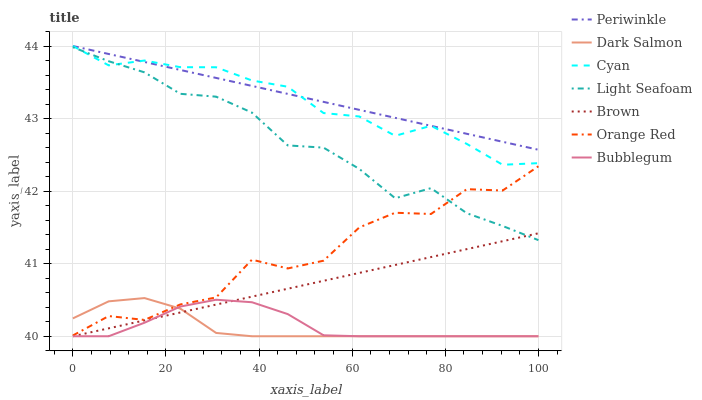Does Dark Salmon have the minimum area under the curve?
Answer yes or no. Yes. Does Periwinkle have the maximum area under the curve?
Answer yes or no. Yes. Does Bubblegum have the minimum area under the curve?
Answer yes or no. No. Does Bubblegum have the maximum area under the curve?
Answer yes or no. No. Is Brown the smoothest?
Answer yes or no. Yes. Is Orange Red the roughest?
Answer yes or no. Yes. Is Dark Salmon the smoothest?
Answer yes or no. No. Is Dark Salmon the roughest?
Answer yes or no. No. Does Brown have the lowest value?
Answer yes or no. Yes. Does Periwinkle have the lowest value?
Answer yes or no. No. Does Cyan have the highest value?
Answer yes or no. Yes. Does Dark Salmon have the highest value?
Answer yes or no. No. Is Dark Salmon less than Light Seafoam?
Answer yes or no. Yes. Is Periwinkle greater than Bubblegum?
Answer yes or no. Yes. Does Bubblegum intersect Brown?
Answer yes or no. Yes. Is Bubblegum less than Brown?
Answer yes or no. No. Is Bubblegum greater than Brown?
Answer yes or no. No. Does Dark Salmon intersect Light Seafoam?
Answer yes or no. No. 